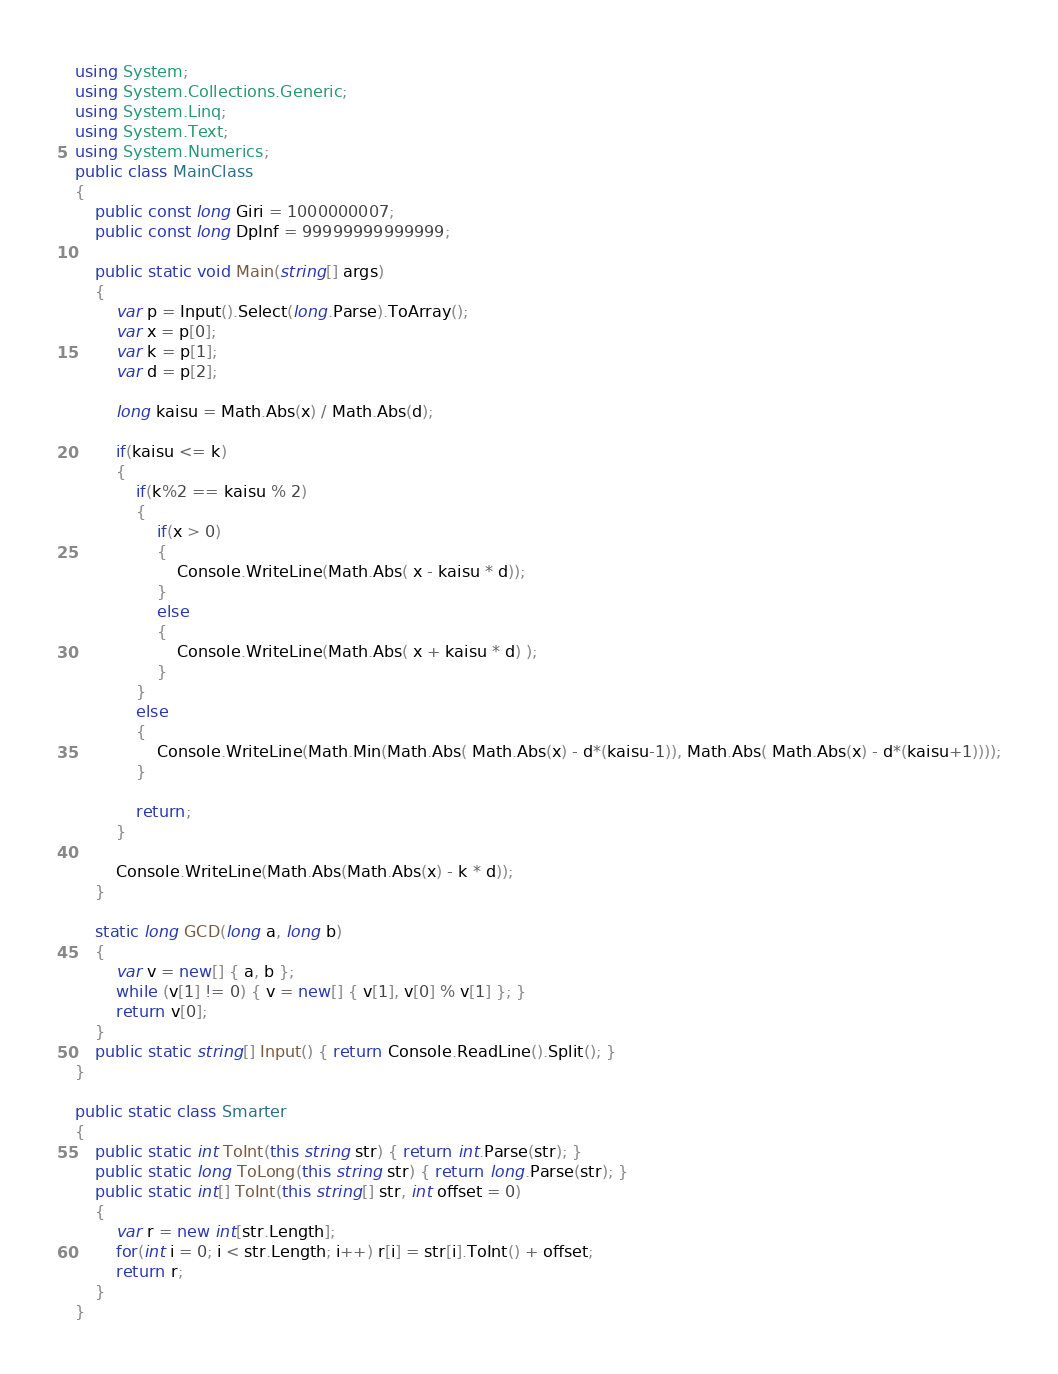Convert code to text. <code><loc_0><loc_0><loc_500><loc_500><_C#_>using System;
using System.Collections.Generic;
using System.Linq;
using System.Text;
using System.Numerics;
public class MainClass
{
	public const long Giri = 1000000007;
	public const long DpInf = 99999999999999;
	
	public static void Main(string[] args)
	{
		var p = Input().Select(long.Parse).ToArray();
		var x = p[0];
		var k = p[1];
		var d = p[2];
		
		long kaisu = Math.Abs(x) / Math.Abs(d);
		
		if(kaisu <= k)
		{
			if(k%2 == kaisu % 2)
			{
				if(x > 0)
				{
					Console.WriteLine(Math.Abs( x - kaisu * d));
				}
				else
				{
					Console.WriteLine(Math.Abs( x + kaisu * d) );
				}
			}
			else
			{
				Console.WriteLine(Math.Min(Math.Abs( Math.Abs(x) - d*(kaisu-1)), Math.Abs( Math.Abs(x) - d*(kaisu+1))));
			}

			return;
		}
		
		Console.WriteLine(Math.Abs(Math.Abs(x) - k * d));
	}
	
	static long GCD(long a, long b)
	{
		var v = new[] { a, b };
		while (v[1] != 0) { v = new[] { v[1], v[0] % v[1] }; }
		return v[0];
	}
	public static string[] Input() { return Console.ReadLine().Split(); }
}

public static class Smarter
{
	public static int ToInt(this string str) { return int.Parse(str); }
	public static long ToLong(this string str) { return long.Parse(str); }
	public static int[] ToInt(this string[] str, int offset = 0)
	{
		var r = new int[str.Length];
		for(int i = 0; i < str.Length; i++) r[i] = str[i].ToInt() + offset;
		return r;
	}
}
</code> 